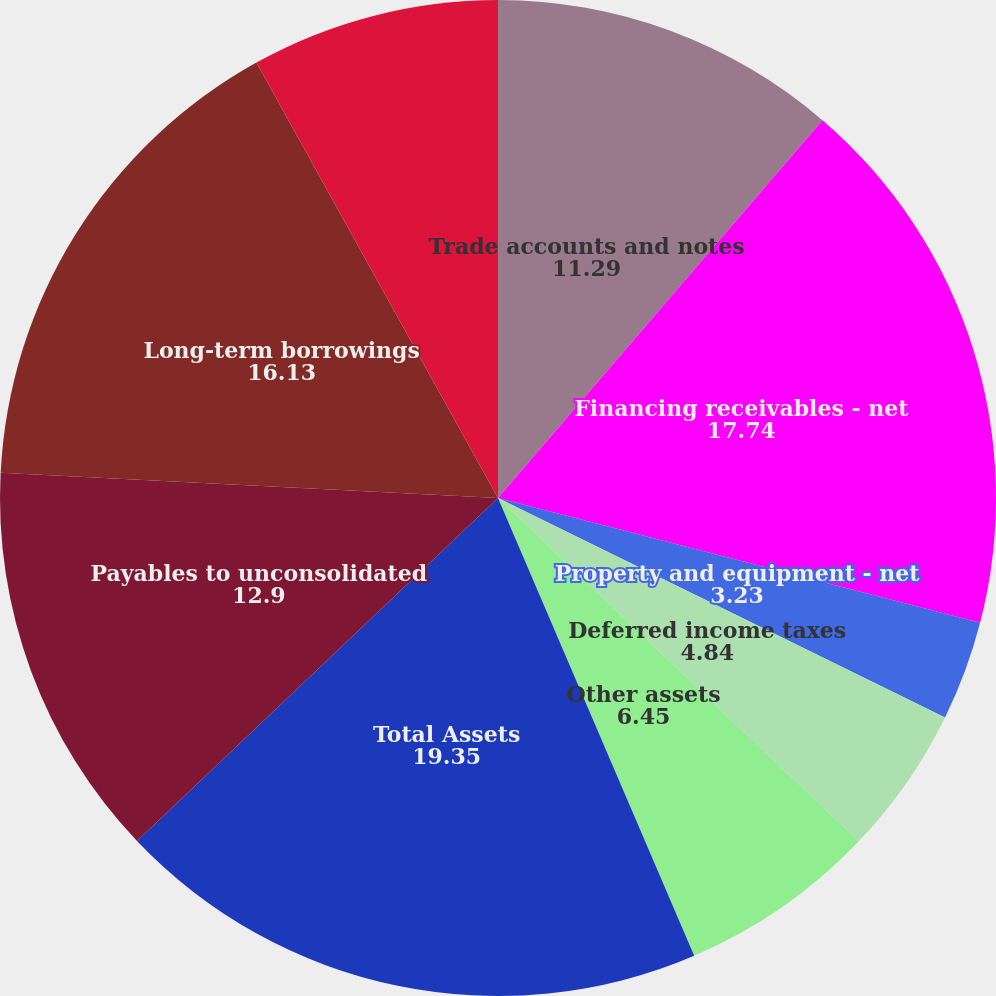Convert chart to OTSL. <chart><loc_0><loc_0><loc_500><loc_500><pie_chart><fcel>Trade accounts and notes<fcel>Financing receivables - net<fcel>Property and equipment - net<fcel>Other intangible assets - net<fcel>Deferred income taxes<fcel>Other assets<fcel>Total Assets<fcel>Payables to unconsolidated<fcel>Long-term borrowings<fcel>Common stock 1 par value<nl><fcel>11.29%<fcel>17.74%<fcel>3.23%<fcel>0.0%<fcel>4.84%<fcel>6.45%<fcel>19.35%<fcel>12.9%<fcel>16.13%<fcel>8.06%<nl></chart> 